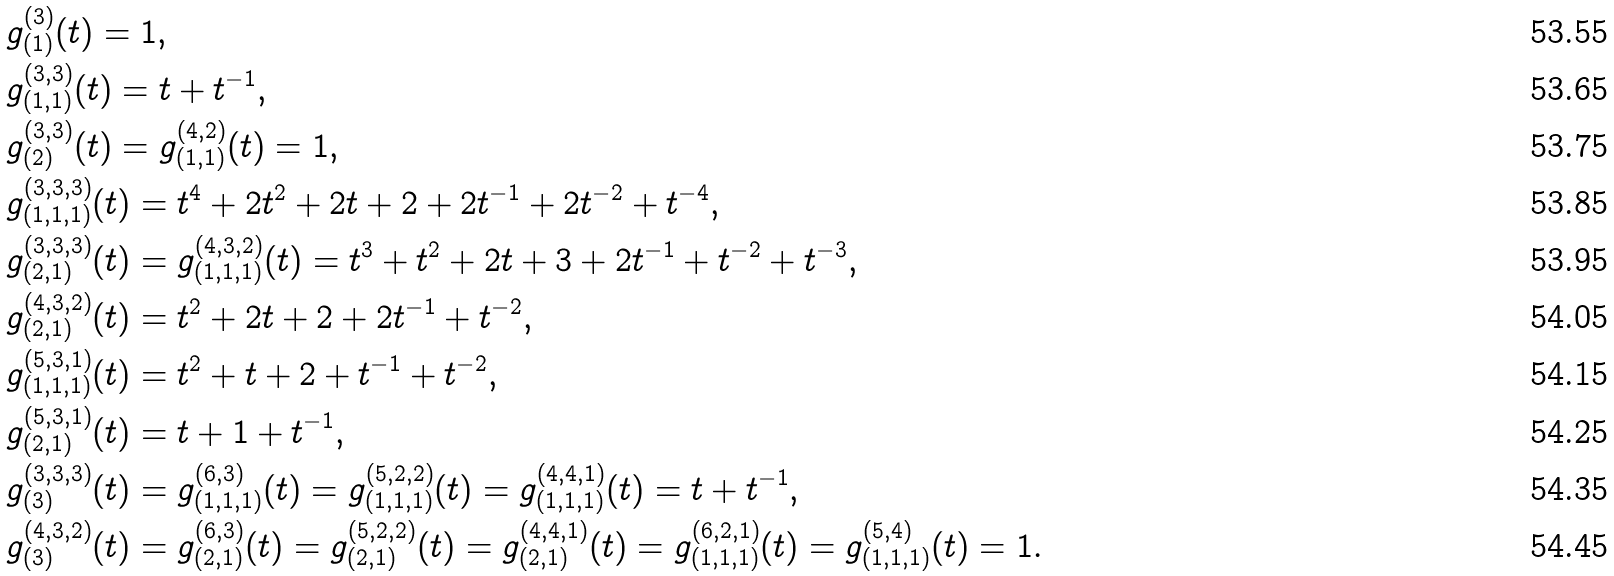Convert formula to latex. <formula><loc_0><loc_0><loc_500><loc_500>& g _ { ( 1 ) } ^ { ( 3 ) } ( t ) = 1 , \\ & g _ { ( 1 , 1 ) } ^ { ( 3 , 3 ) } ( t ) = t + t ^ { - 1 } , \\ & g _ { ( 2 ) } ^ { ( 3 , 3 ) } ( t ) = g _ { ( 1 , 1 ) } ^ { ( 4 , 2 ) } ( t ) = 1 , \\ & g _ { ( 1 , 1 , 1 ) } ^ { ( 3 , 3 , 3 ) } ( t ) = t ^ { 4 } + 2 t ^ { 2 } + 2 t + 2 + 2 t ^ { - 1 } + 2 t ^ { - 2 } + t ^ { - 4 } , \\ & g _ { ( 2 , 1 ) } ^ { ( 3 , 3 , 3 ) } ( t ) = g _ { ( 1 , 1 , 1 ) } ^ { ( 4 , 3 , 2 ) } ( t ) = t ^ { 3 } + t ^ { 2 } + 2 t + 3 + 2 t ^ { - 1 } + t ^ { - 2 } + t ^ { - 3 } , \\ & g _ { ( 2 , 1 ) } ^ { ( 4 , 3 , 2 ) } ( t ) = t ^ { 2 } + 2 t + 2 + 2 t ^ { - 1 } + t ^ { - 2 } , \\ & g _ { ( 1 , 1 , 1 ) } ^ { ( 5 , 3 , 1 ) } ( t ) = t ^ { 2 } + t + 2 + t ^ { - 1 } + t ^ { - 2 } , \\ & g _ { ( 2 , 1 ) } ^ { ( 5 , 3 , 1 ) } ( t ) = t + 1 + t ^ { - 1 } , \\ & g _ { ( 3 ) } ^ { ( 3 , 3 , 3 ) } ( t ) = g _ { ( 1 , 1 , 1 ) } ^ { ( 6 , 3 ) } ( t ) = g _ { ( 1 , 1 , 1 ) } ^ { ( 5 , 2 , 2 ) } ( t ) = g _ { ( 1 , 1 , 1 ) } ^ { ( 4 , 4 , 1 ) } ( t ) = t + t ^ { - 1 } , \\ & g _ { ( 3 ) } ^ { ( 4 , 3 , 2 ) } ( t ) = g _ { ( 2 , 1 ) } ^ { ( 6 , 3 ) } ( t ) = g _ { ( 2 , 1 ) } ^ { ( 5 , 2 , 2 ) } ( t ) = g _ { ( 2 , 1 ) } ^ { ( 4 , 4 , 1 ) } ( t ) = g _ { ( 1 , 1 , 1 ) } ^ { ( 6 , 2 , 1 ) } ( t ) = g _ { ( 1 , 1 , 1 ) } ^ { ( 5 , 4 ) } ( t ) = 1 .</formula> 